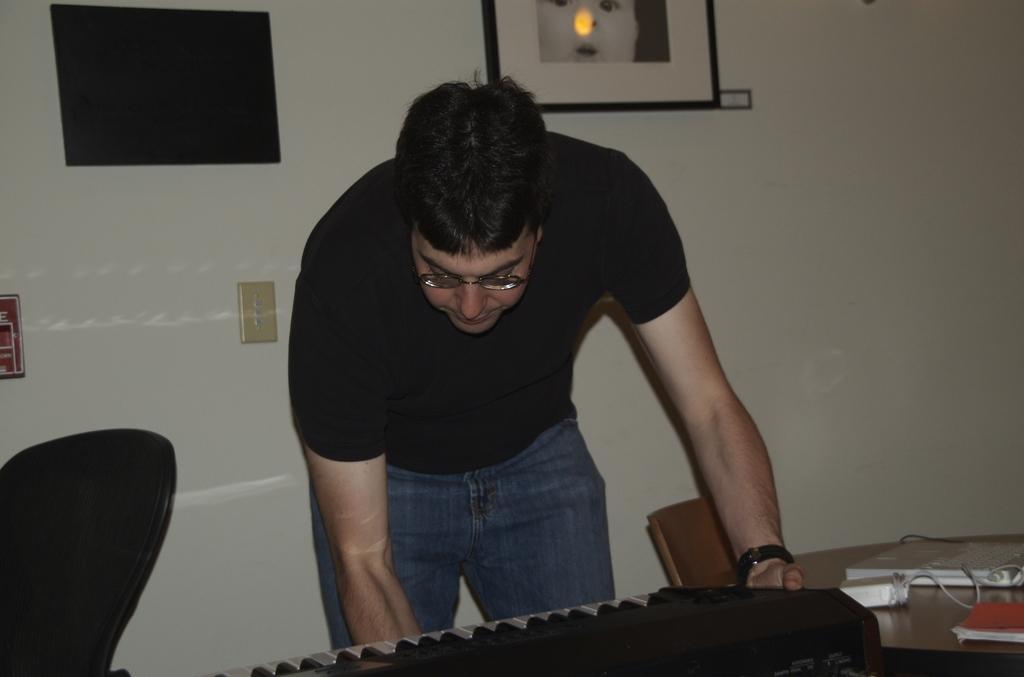How would you summarize this image in a sentence or two? In this image the person is standing. In front there is a piano. On the table there is a book. There is a chair. At the back side there is a frame. 